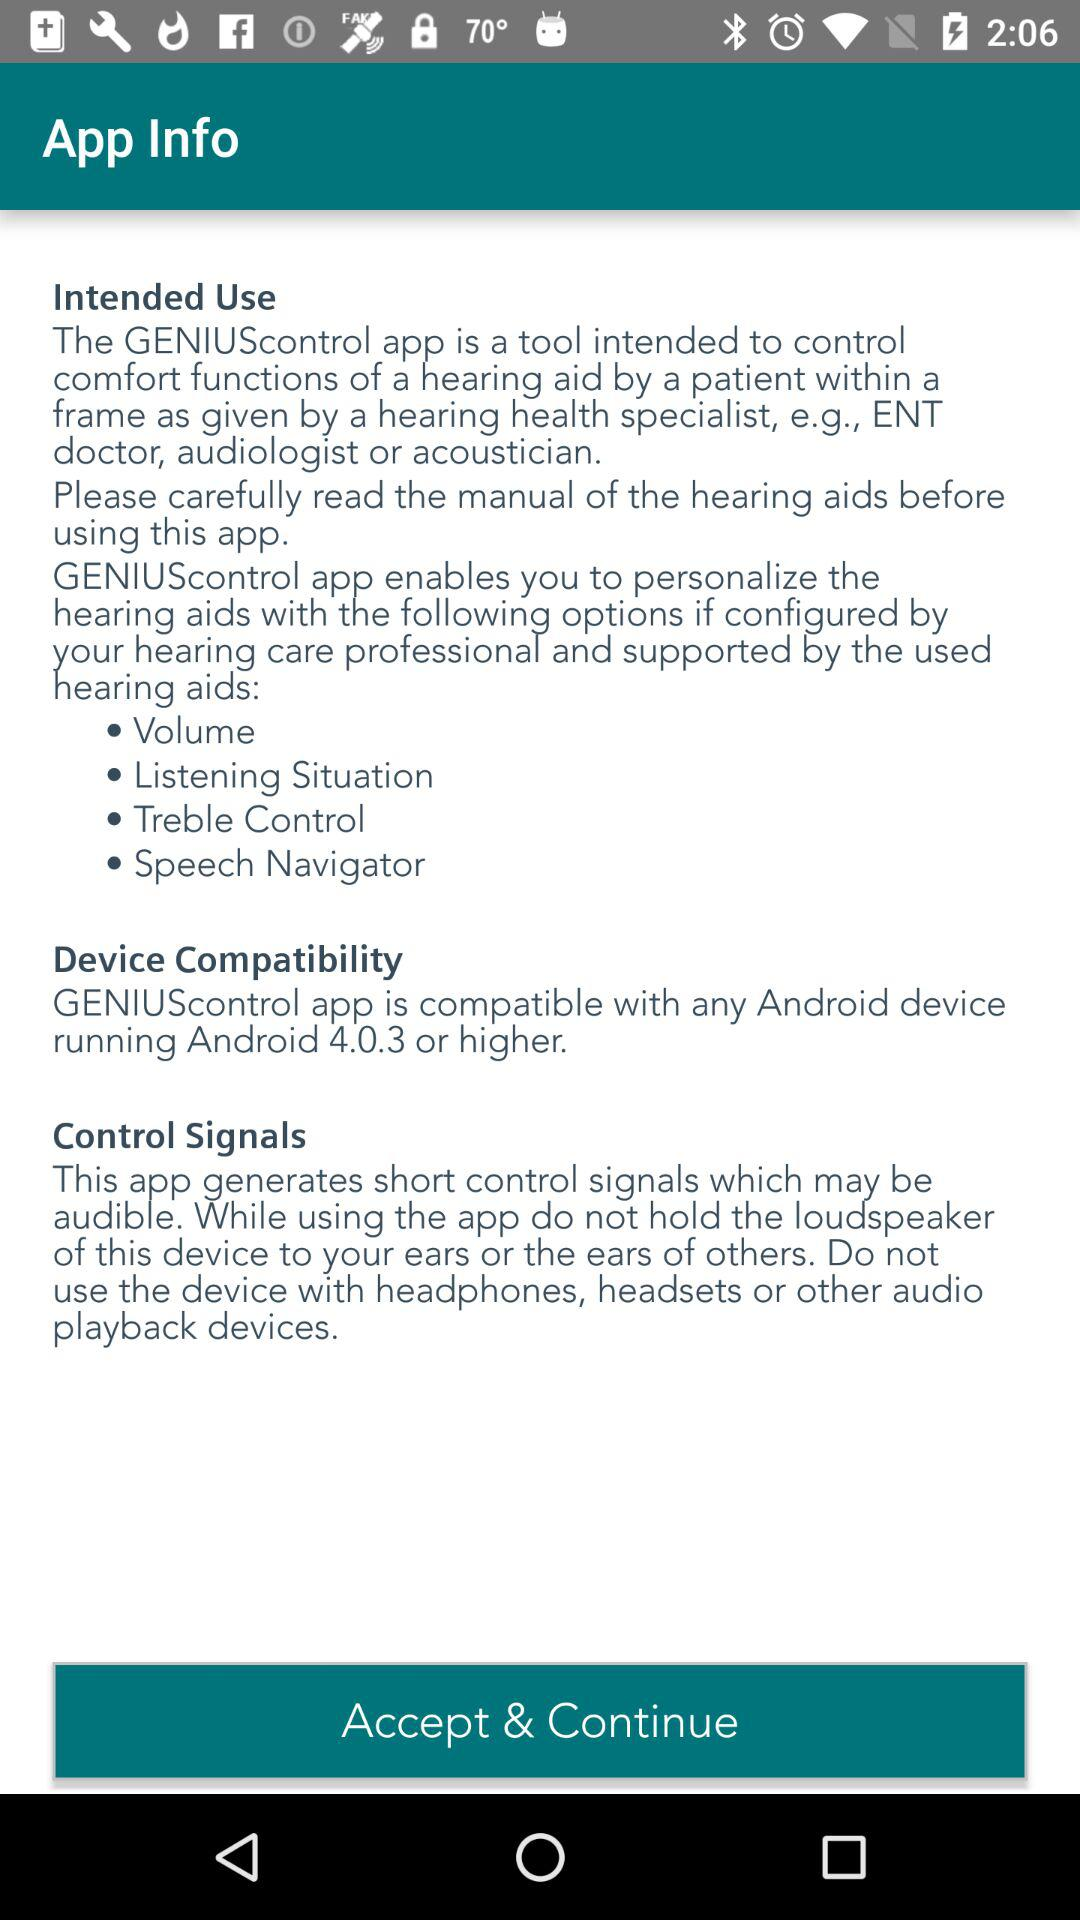What is the minimum version of Android required to run this app?
Answer the question using a single word or phrase. Android 4.0.3 